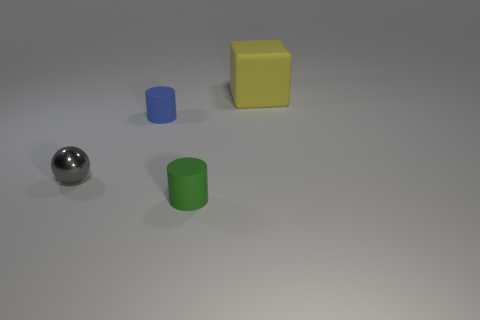What size is the yellow rubber block?
Keep it short and to the point. Large. Is there a tiny green object that has the same material as the gray ball?
Offer a terse response. No. What is the size of the blue matte object that is the same shape as the green thing?
Give a very brief answer. Small. Is the number of gray shiny spheres left of the green matte object the same as the number of tiny cyan metal blocks?
Keep it short and to the point. No. There is a small rubber thing in front of the metal sphere; does it have the same shape as the small gray thing?
Keep it short and to the point. No. What shape is the tiny shiny thing?
Ensure brevity in your answer.  Sphere. The small object right of the cylinder behind the small thing on the right side of the tiny blue matte cylinder is made of what material?
Provide a short and direct response. Rubber. What number of things are either brown rubber cylinders or large yellow objects?
Offer a terse response. 1. Is the object in front of the small sphere made of the same material as the small gray ball?
Your answer should be very brief. No. How many things are either objects that are on the left side of the large rubber block or yellow cylinders?
Offer a very short reply. 3. 